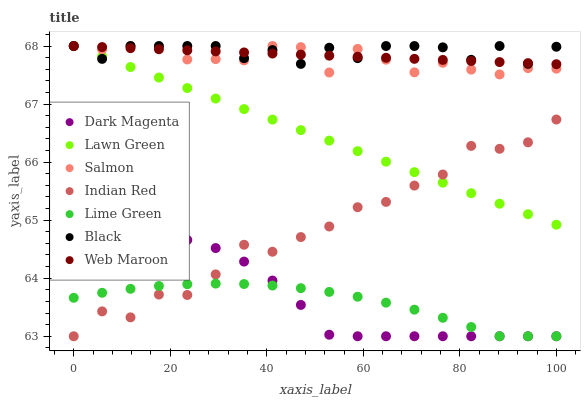Does Lime Green have the minimum area under the curve?
Answer yes or no. Yes. Does Black have the maximum area under the curve?
Answer yes or no. Yes. Does Dark Magenta have the minimum area under the curve?
Answer yes or no. No. Does Dark Magenta have the maximum area under the curve?
Answer yes or no. No. Is Web Maroon the smoothest?
Answer yes or no. Yes. Is Black the roughest?
Answer yes or no. Yes. Is Dark Magenta the smoothest?
Answer yes or no. No. Is Dark Magenta the roughest?
Answer yes or no. No. Does Dark Magenta have the lowest value?
Answer yes or no. Yes. Does Web Maroon have the lowest value?
Answer yes or no. No. Does Black have the highest value?
Answer yes or no. Yes. Does Dark Magenta have the highest value?
Answer yes or no. No. Is Dark Magenta less than Web Maroon?
Answer yes or no. Yes. Is Black greater than Indian Red?
Answer yes or no. Yes. Does Web Maroon intersect Lawn Green?
Answer yes or no. Yes. Is Web Maroon less than Lawn Green?
Answer yes or no. No. Is Web Maroon greater than Lawn Green?
Answer yes or no. No. Does Dark Magenta intersect Web Maroon?
Answer yes or no. No. 